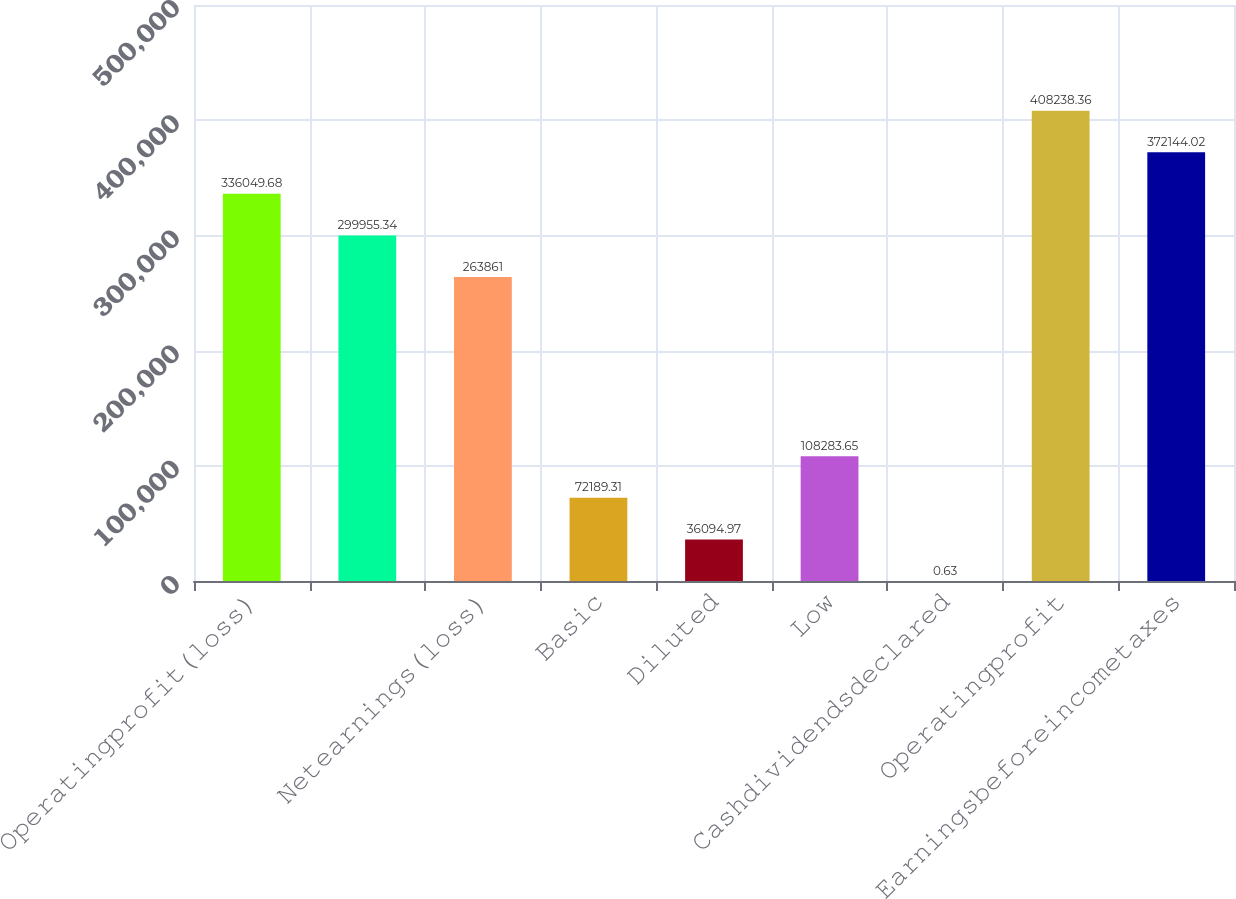Convert chart to OTSL. <chart><loc_0><loc_0><loc_500><loc_500><bar_chart><fcel>Operatingprofit(loss)<fcel>Unnamed: 1<fcel>Netearnings(loss)<fcel>Basic<fcel>Diluted<fcel>Low<fcel>Cashdividendsdeclared<fcel>Operatingprofit<fcel>Earningsbeforeincometaxes<nl><fcel>336050<fcel>299955<fcel>263861<fcel>72189.3<fcel>36095<fcel>108284<fcel>0.63<fcel>408238<fcel>372144<nl></chart> 